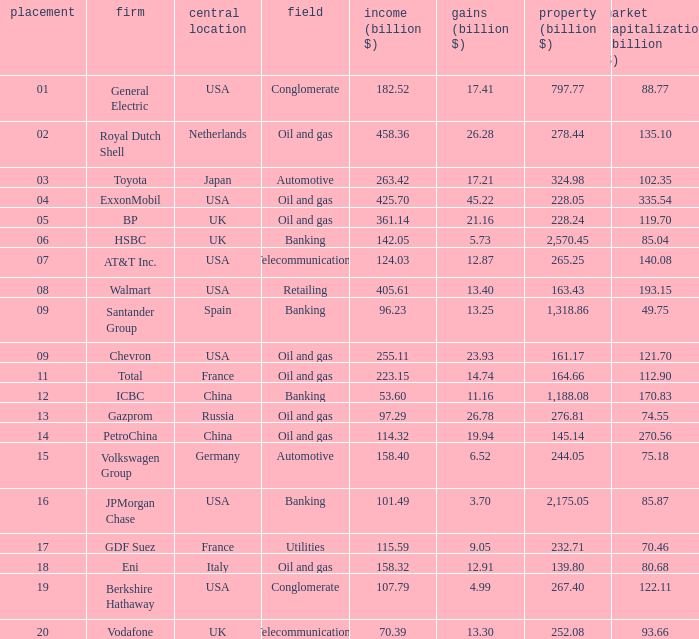7? None. 